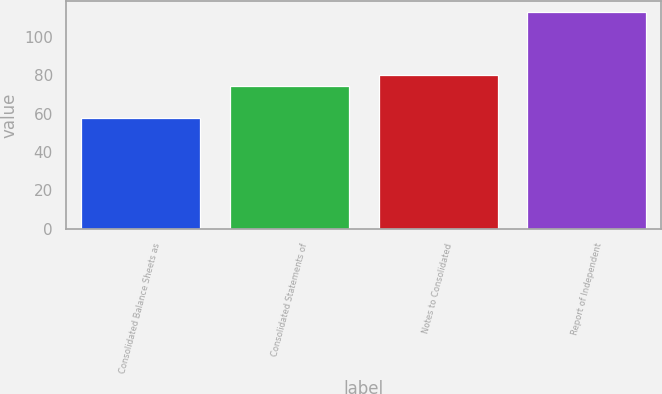<chart> <loc_0><loc_0><loc_500><loc_500><bar_chart><fcel>Consolidated Balance Sheets as<fcel>Consolidated Statements of<fcel>Notes to Consolidated<fcel>Report of Independent<nl><fcel>58<fcel>74.5<fcel>80<fcel>113<nl></chart> 